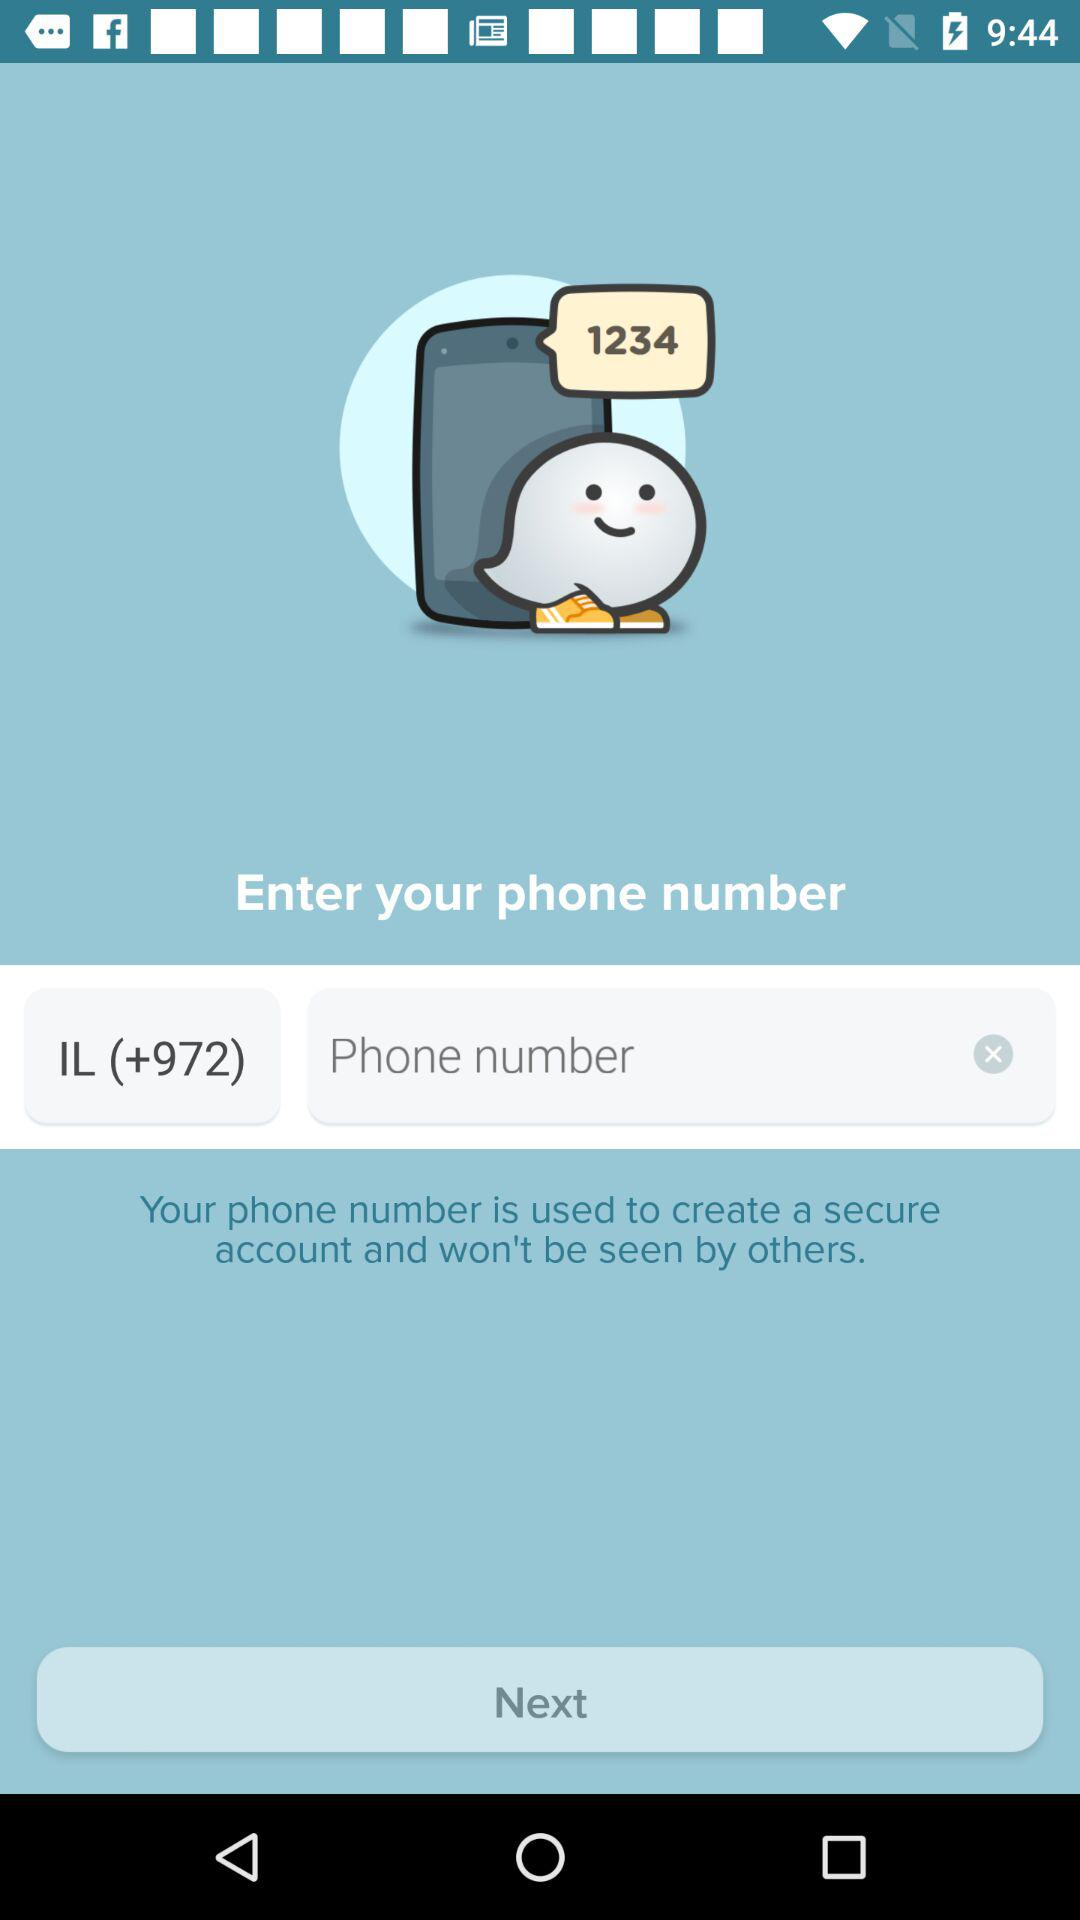What's the country code? The country code is +972. 